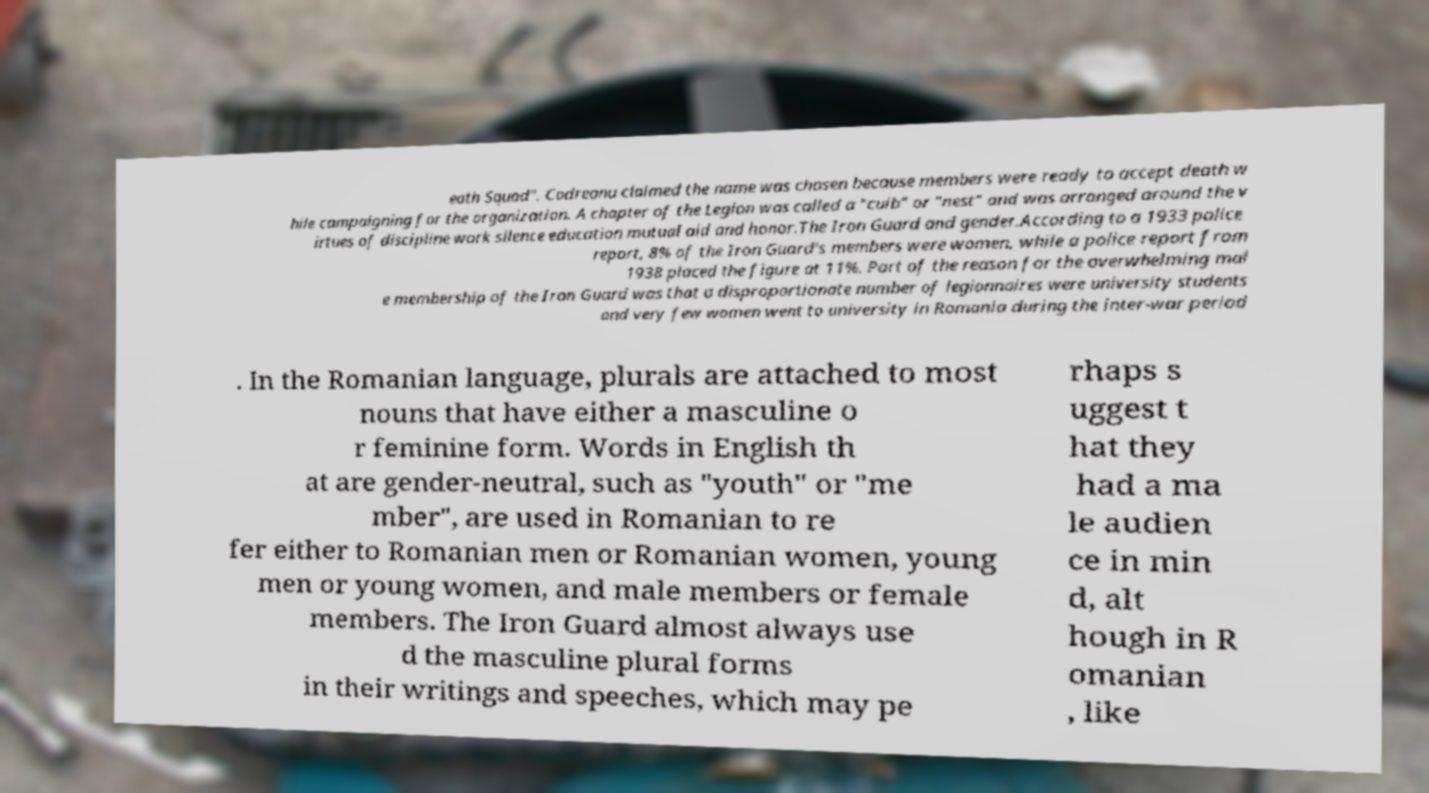Can you accurately transcribe the text from the provided image for me? eath Squad". Codreanu claimed the name was chosen because members were ready to accept death w hile campaigning for the organization. A chapter of the Legion was called a "cuib" or "nest" and was arranged around the v irtues of discipline work silence education mutual aid and honor.The Iron Guard and gender.According to a 1933 police report, 8% of the Iron Guard's members were women, while a police report from 1938 placed the figure at 11%. Part of the reason for the overwhelming mal e membership of the Iron Guard was that a disproportionate number of legionnaires were university students and very few women went to university in Romania during the inter-war period . In the Romanian language, plurals are attached to most nouns that have either a masculine o r feminine form. Words in English th at are gender-neutral, such as "youth" or "me mber", are used in Romanian to re fer either to Romanian men or Romanian women, young men or young women, and male members or female members. The Iron Guard almost always use d the masculine plural forms in their writings and speeches, which may pe rhaps s uggest t hat they had a ma le audien ce in min d, alt hough in R omanian , like 